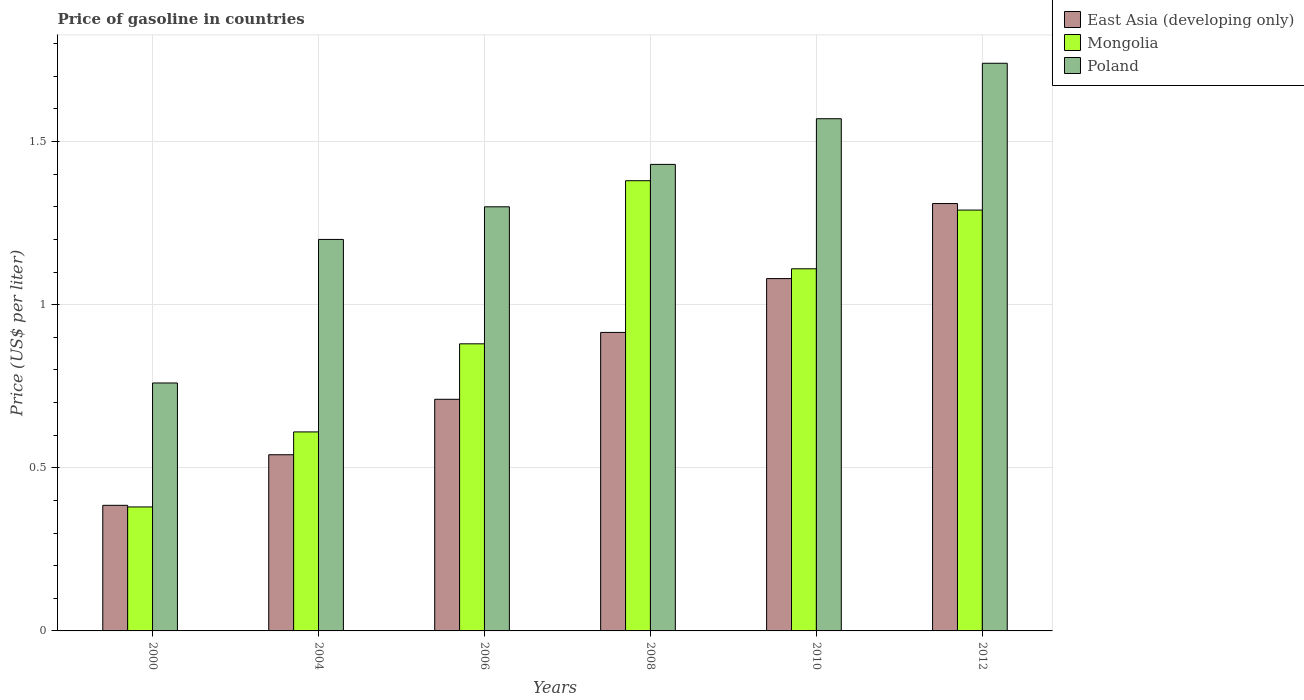How many different coloured bars are there?
Make the answer very short. 3. Are the number of bars per tick equal to the number of legend labels?
Your response must be concise. Yes. Are the number of bars on each tick of the X-axis equal?
Make the answer very short. Yes. How many bars are there on the 6th tick from the left?
Your answer should be very brief. 3. How many bars are there on the 5th tick from the right?
Ensure brevity in your answer.  3. What is the label of the 6th group of bars from the left?
Your answer should be compact. 2012. What is the price of gasoline in Poland in 2012?
Make the answer very short. 1.74. Across all years, what is the maximum price of gasoline in Mongolia?
Offer a very short reply. 1.38. Across all years, what is the minimum price of gasoline in East Asia (developing only)?
Offer a terse response. 0.39. In which year was the price of gasoline in East Asia (developing only) maximum?
Your answer should be compact. 2012. What is the total price of gasoline in East Asia (developing only) in the graph?
Your answer should be compact. 4.94. What is the difference between the price of gasoline in East Asia (developing only) in 2006 and that in 2010?
Ensure brevity in your answer.  -0.37. What is the difference between the price of gasoline in East Asia (developing only) in 2000 and the price of gasoline in Poland in 2010?
Offer a terse response. -1.19. What is the average price of gasoline in Poland per year?
Keep it short and to the point. 1.33. In the year 2012, what is the difference between the price of gasoline in Mongolia and price of gasoline in Poland?
Make the answer very short. -0.45. What is the ratio of the price of gasoline in Poland in 2006 to that in 2008?
Your answer should be compact. 0.91. What is the difference between the highest and the second highest price of gasoline in Mongolia?
Your response must be concise. 0.09. What does the 2nd bar from the left in 2000 represents?
Your response must be concise. Mongolia. Is it the case that in every year, the sum of the price of gasoline in East Asia (developing only) and price of gasoline in Mongolia is greater than the price of gasoline in Poland?
Keep it short and to the point. No. Are all the bars in the graph horizontal?
Keep it short and to the point. No. How many years are there in the graph?
Offer a very short reply. 6. What is the difference between two consecutive major ticks on the Y-axis?
Your answer should be compact. 0.5. Are the values on the major ticks of Y-axis written in scientific E-notation?
Offer a very short reply. No. Where does the legend appear in the graph?
Offer a very short reply. Top right. How are the legend labels stacked?
Ensure brevity in your answer.  Vertical. What is the title of the graph?
Ensure brevity in your answer.  Price of gasoline in countries. What is the label or title of the X-axis?
Provide a short and direct response. Years. What is the label or title of the Y-axis?
Give a very brief answer. Price (US$ per liter). What is the Price (US$ per liter) of East Asia (developing only) in 2000?
Your answer should be very brief. 0.39. What is the Price (US$ per liter) of Mongolia in 2000?
Provide a short and direct response. 0.38. What is the Price (US$ per liter) in Poland in 2000?
Provide a short and direct response. 0.76. What is the Price (US$ per liter) of East Asia (developing only) in 2004?
Make the answer very short. 0.54. What is the Price (US$ per liter) in Mongolia in 2004?
Your answer should be very brief. 0.61. What is the Price (US$ per liter) in East Asia (developing only) in 2006?
Ensure brevity in your answer.  0.71. What is the Price (US$ per liter) in Poland in 2006?
Make the answer very short. 1.3. What is the Price (US$ per liter) in East Asia (developing only) in 2008?
Offer a terse response. 0.92. What is the Price (US$ per liter) of Mongolia in 2008?
Provide a succinct answer. 1.38. What is the Price (US$ per liter) of Poland in 2008?
Your response must be concise. 1.43. What is the Price (US$ per liter) in East Asia (developing only) in 2010?
Make the answer very short. 1.08. What is the Price (US$ per liter) of Mongolia in 2010?
Give a very brief answer. 1.11. What is the Price (US$ per liter) of Poland in 2010?
Your answer should be very brief. 1.57. What is the Price (US$ per liter) in East Asia (developing only) in 2012?
Your answer should be compact. 1.31. What is the Price (US$ per liter) of Mongolia in 2012?
Offer a very short reply. 1.29. What is the Price (US$ per liter) of Poland in 2012?
Offer a very short reply. 1.74. Across all years, what is the maximum Price (US$ per liter) in East Asia (developing only)?
Make the answer very short. 1.31. Across all years, what is the maximum Price (US$ per liter) of Mongolia?
Provide a short and direct response. 1.38. Across all years, what is the maximum Price (US$ per liter) in Poland?
Give a very brief answer. 1.74. Across all years, what is the minimum Price (US$ per liter) of East Asia (developing only)?
Offer a very short reply. 0.39. Across all years, what is the minimum Price (US$ per liter) of Mongolia?
Your response must be concise. 0.38. Across all years, what is the minimum Price (US$ per liter) in Poland?
Keep it short and to the point. 0.76. What is the total Price (US$ per liter) in East Asia (developing only) in the graph?
Provide a succinct answer. 4.94. What is the total Price (US$ per liter) in Mongolia in the graph?
Offer a terse response. 5.65. What is the difference between the Price (US$ per liter) of East Asia (developing only) in 2000 and that in 2004?
Keep it short and to the point. -0.15. What is the difference between the Price (US$ per liter) in Mongolia in 2000 and that in 2004?
Provide a short and direct response. -0.23. What is the difference between the Price (US$ per liter) of Poland in 2000 and that in 2004?
Offer a terse response. -0.44. What is the difference between the Price (US$ per liter) of East Asia (developing only) in 2000 and that in 2006?
Provide a succinct answer. -0.33. What is the difference between the Price (US$ per liter) of Poland in 2000 and that in 2006?
Provide a short and direct response. -0.54. What is the difference between the Price (US$ per liter) of East Asia (developing only) in 2000 and that in 2008?
Make the answer very short. -0.53. What is the difference between the Price (US$ per liter) in Mongolia in 2000 and that in 2008?
Keep it short and to the point. -1. What is the difference between the Price (US$ per liter) in Poland in 2000 and that in 2008?
Keep it short and to the point. -0.67. What is the difference between the Price (US$ per liter) in East Asia (developing only) in 2000 and that in 2010?
Ensure brevity in your answer.  -0.69. What is the difference between the Price (US$ per liter) in Mongolia in 2000 and that in 2010?
Your answer should be very brief. -0.73. What is the difference between the Price (US$ per liter) of Poland in 2000 and that in 2010?
Offer a terse response. -0.81. What is the difference between the Price (US$ per liter) in East Asia (developing only) in 2000 and that in 2012?
Your answer should be very brief. -0.93. What is the difference between the Price (US$ per liter) of Mongolia in 2000 and that in 2012?
Offer a terse response. -0.91. What is the difference between the Price (US$ per liter) of Poland in 2000 and that in 2012?
Your answer should be very brief. -0.98. What is the difference between the Price (US$ per liter) of East Asia (developing only) in 2004 and that in 2006?
Your answer should be compact. -0.17. What is the difference between the Price (US$ per liter) in Mongolia in 2004 and that in 2006?
Your answer should be very brief. -0.27. What is the difference between the Price (US$ per liter) of East Asia (developing only) in 2004 and that in 2008?
Provide a short and direct response. -0.38. What is the difference between the Price (US$ per liter) in Mongolia in 2004 and that in 2008?
Offer a terse response. -0.77. What is the difference between the Price (US$ per liter) of Poland in 2004 and that in 2008?
Keep it short and to the point. -0.23. What is the difference between the Price (US$ per liter) of East Asia (developing only) in 2004 and that in 2010?
Keep it short and to the point. -0.54. What is the difference between the Price (US$ per liter) in Mongolia in 2004 and that in 2010?
Keep it short and to the point. -0.5. What is the difference between the Price (US$ per liter) in Poland in 2004 and that in 2010?
Offer a very short reply. -0.37. What is the difference between the Price (US$ per liter) of East Asia (developing only) in 2004 and that in 2012?
Provide a succinct answer. -0.77. What is the difference between the Price (US$ per liter) of Mongolia in 2004 and that in 2012?
Ensure brevity in your answer.  -0.68. What is the difference between the Price (US$ per liter) in Poland in 2004 and that in 2012?
Your response must be concise. -0.54. What is the difference between the Price (US$ per liter) of East Asia (developing only) in 2006 and that in 2008?
Offer a very short reply. -0.2. What is the difference between the Price (US$ per liter) in Mongolia in 2006 and that in 2008?
Ensure brevity in your answer.  -0.5. What is the difference between the Price (US$ per liter) of Poland in 2006 and that in 2008?
Keep it short and to the point. -0.13. What is the difference between the Price (US$ per liter) of East Asia (developing only) in 2006 and that in 2010?
Offer a terse response. -0.37. What is the difference between the Price (US$ per liter) of Mongolia in 2006 and that in 2010?
Offer a very short reply. -0.23. What is the difference between the Price (US$ per liter) of Poland in 2006 and that in 2010?
Ensure brevity in your answer.  -0.27. What is the difference between the Price (US$ per liter) of East Asia (developing only) in 2006 and that in 2012?
Offer a very short reply. -0.6. What is the difference between the Price (US$ per liter) in Mongolia in 2006 and that in 2012?
Your answer should be compact. -0.41. What is the difference between the Price (US$ per liter) in Poland in 2006 and that in 2012?
Provide a succinct answer. -0.44. What is the difference between the Price (US$ per liter) of East Asia (developing only) in 2008 and that in 2010?
Your response must be concise. -0.17. What is the difference between the Price (US$ per liter) in Mongolia in 2008 and that in 2010?
Keep it short and to the point. 0.27. What is the difference between the Price (US$ per liter) of Poland in 2008 and that in 2010?
Give a very brief answer. -0.14. What is the difference between the Price (US$ per liter) in East Asia (developing only) in 2008 and that in 2012?
Make the answer very short. -0.4. What is the difference between the Price (US$ per liter) in Mongolia in 2008 and that in 2012?
Offer a very short reply. 0.09. What is the difference between the Price (US$ per liter) in Poland in 2008 and that in 2012?
Provide a short and direct response. -0.31. What is the difference between the Price (US$ per liter) of East Asia (developing only) in 2010 and that in 2012?
Offer a very short reply. -0.23. What is the difference between the Price (US$ per liter) of Mongolia in 2010 and that in 2012?
Ensure brevity in your answer.  -0.18. What is the difference between the Price (US$ per liter) in Poland in 2010 and that in 2012?
Provide a succinct answer. -0.17. What is the difference between the Price (US$ per liter) of East Asia (developing only) in 2000 and the Price (US$ per liter) of Mongolia in 2004?
Your answer should be very brief. -0.23. What is the difference between the Price (US$ per liter) of East Asia (developing only) in 2000 and the Price (US$ per liter) of Poland in 2004?
Ensure brevity in your answer.  -0.81. What is the difference between the Price (US$ per liter) of Mongolia in 2000 and the Price (US$ per liter) of Poland in 2004?
Your answer should be very brief. -0.82. What is the difference between the Price (US$ per liter) in East Asia (developing only) in 2000 and the Price (US$ per liter) in Mongolia in 2006?
Offer a very short reply. -0.49. What is the difference between the Price (US$ per liter) in East Asia (developing only) in 2000 and the Price (US$ per liter) in Poland in 2006?
Offer a very short reply. -0.92. What is the difference between the Price (US$ per liter) in Mongolia in 2000 and the Price (US$ per liter) in Poland in 2006?
Make the answer very short. -0.92. What is the difference between the Price (US$ per liter) of East Asia (developing only) in 2000 and the Price (US$ per liter) of Mongolia in 2008?
Your answer should be very brief. -0.99. What is the difference between the Price (US$ per liter) of East Asia (developing only) in 2000 and the Price (US$ per liter) of Poland in 2008?
Your answer should be compact. -1.04. What is the difference between the Price (US$ per liter) in Mongolia in 2000 and the Price (US$ per liter) in Poland in 2008?
Keep it short and to the point. -1.05. What is the difference between the Price (US$ per liter) in East Asia (developing only) in 2000 and the Price (US$ per liter) in Mongolia in 2010?
Ensure brevity in your answer.  -0.72. What is the difference between the Price (US$ per liter) in East Asia (developing only) in 2000 and the Price (US$ per liter) in Poland in 2010?
Your answer should be very brief. -1.19. What is the difference between the Price (US$ per liter) in Mongolia in 2000 and the Price (US$ per liter) in Poland in 2010?
Provide a succinct answer. -1.19. What is the difference between the Price (US$ per liter) in East Asia (developing only) in 2000 and the Price (US$ per liter) in Mongolia in 2012?
Make the answer very short. -0.91. What is the difference between the Price (US$ per liter) in East Asia (developing only) in 2000 and the Price (US$ per liter) in Poland in 2012?
Give a very brief answer. -1.35. What is the difference between the Price (US$ per liter) of Mongolia in 2000 and the Price (US$ per liter) of Poland in 2012?
Offer a terse response. -1.36. What is the difference between the Price (US$ per liter) in East Asia (developing only) in 2004 and the Price (US$ per liter) in Mongolia in 2006?
Your answer should be very brief. -0.34. What is the difference between the Price (US$ per liter) in East Asia (developing only) in 2004 and the Price (US$ per liter) in Poland in 2006?
Your response must be concise. -0.76. What is the difference between the Price (US$ per liter) in Mongolia in 2004 and the Price (US$ per liter) in Poland in 2006?
Provide a succinct answer. -0.69. What is the difference between the Price (US$ per liter) in East Asia (developing only) in 2004 and the Price (US$ per liter) in Mongolia in 2008?
Your response must be concise. -0.84. What is the difference between the Price (US$ per liter) of East Asia (developing only) in 2004 and the Price (US$ per liter) of Poland in 2008?
Keep it short and to the point. -0.89. What is the difference between the Price (US$ per liter) in Mongolia in 2004 and the Price (US$ per liter) in Poland in 2008?
Offer a very short reply. -0.82. What is the difference between the Price (US$ per liter) of East Asia (developing only) in 2004 and the Price (US$ per liter) of Mongolia in 2010?
Make the answer very short. -0.57. What is the difference between the Price (US$ per liter) of East Asia (developing only) in 2004 and the Price (US$ per liter) of Poland in 2010?
Offer a very short reply. -1.03. What is the difference between the Price (US$ per liter) in Mongolia in 2004 and the Price (US$ per liter) in Poland in 2010?
Your response must be concise. -0.96. What is the difference between the Price (US$ per liter) of East Asia (developing only) in 2004 and the Price (US$ per liter) of Mongolia in 2012?
Give a very brief answer. -0.75. What is the difference between the Price (US$ per liter) of East Asia (developing only) in 2004 and the Price (US$ per liter) of Poland in 2012?
Offer a very short reply. -1.2. What is the difference between the Price (US$ per liter) of Mongolia in 2004 and the Price (US$ per liter) of Poland in 2012?
Your answer should be compact. -1.13. What is the difference between the Price (US$ per liter) of East Asia (developing only) in 2006 and the Price (US$ per liter) of Mongolia in 2008?
Provide a short and direct response. -0.67. What is the difference between the Price (US$ per liter) of East Asia (developing only) in 2006 and the Price (US$ per liter) of Poland in 2008?
Your answer should be compact. -0.72. What is the difference between the Price (US$ per liter) of Mongolia in 2006 and the Price (US$ per liter) of Poland in 2008?
Offer a very short reply. -0.55. What is the difference between the Price (US$ per liter) in East Asia (developing only) in 2006 and the Price (US$ per liter) in Poland in 2010?
Keep it short and to the point. -0.86. What is the difference between the Price (US$ per liter) in Mongolia in 2006 and the Price (US$ per liter) in Poland in 2010?
Your answer should be very brief. -0.69. What is the difference between the Price (US$ per liter) of East Asia (developing only) in 2006 and the Price (US$ per liter) of Mongolia in 2012?
Offer a very short reply. -0.58. What is the difference between the Price (US$ per liter) in East Asia (developing only) in 2006 and the Price (US$ per liter) in Poland in 2012?
Offer a terse response. -1.03. What is the difference between the Price (US$ per liter) of Mongolia in 2006 and the Price (US$ per liter) of Poland in 2012?
Give a very brief answer. -0.86. What is the difference between the Price (US$ per liter) of East Asia (developing only) in 2008 and the Price (US$ per liter) of Mongolia in 2010?
Keep it short and to the point. -0.2. What is the difference between the Price (US$ per liter) of East Asia (developing only) in 2008 and the Price (US$ per liter) of Poland in 2010?
Give a very brief answer. -0.66. What is the difference between the Price (US$ per liter) in Mongolia in 2008 and the Price (US$ per liter) in Poland in 2010?
Provide a short and direct response. -0.19. What is the difference between the Price (US$ per liter) in East Asia (developing only) in 2008 and the Price (US$ per liter) in Mongolia in 2012?
Offer a very short reply. -0.38. What is the difference between the Price (US$ per liter) in East Asia (developing only) in 2008 and the Price (US$ per liter) in Poland in 2012?
Ensure brevity in your answer.  -0.82. What is the difference between the Price (US$ per liter) of Mongolia in 2008 and the Price (US$ per liter) of Poland in 2012?
Give a very brief answer. -0.36. What is the difference between the Price (US$ per liter) of East Asia (developing only) in 2010 and the Price (US$ per liter) of Mongolia in 2012?
Your response must be concise. -0.21. What is the difference between the Price (US$ per liter) in East Asia (developing only) in 2010 and the Price (US$ per liter) in Poland in 2012?
Your answer should be compact. -0.66. What is the difference between the Price (US$ per liter) in Mongolia in 2010 and the Price (US$ per liter) in Poland in 2012?
Provide a short and direct response. -0.63. What is the average Price (US$ per liter) in East Asia (developing only) per year?
Provide a short and direct response. 0.82. What is the average Price (US$ per liter) in Mongolia per year?
Your answer should be compact. 0.94. What is the average Price (US$ per liter) in Poland per year?
Keep it short and to the point. 1.33. In the year 2000, what is the difference between the Price (US$ per liter) of East Asia (developing only) and Price (US$ per liter) of Mongolia?
Make the answer very short. 0.01. In the year 2000, what is the difference between the Price (US$ per liter) in East Asia (developing only) and Price (US$ per liter) in Poland?
Offer a very short reply. -0.38. In the year 2000, what is the difference between the Price (US$ per liter) in Mongolia and Price (US$ per liter) in Poland?
Your response must be concise. -0.38. In the year 2004, what is the difference between the Price (US$ per liter) in East Asia (developing only) and Price (US$ per liter) in Mongolia?
Ensure brevity in your answer.  -0.07. In the year 2004, what is the difference between the Price (US$ per liter) in East Asia (developing only) and Price (US$ per liter) in Poland?
Provide a succinct answer. -0.66. In the year 2004, what is the difference between the Price (US$ per liter) in Mongolia and Price (US$ per liter) in Poland?
Offer a very short reply. -0.59. In the year 2006, what is the difference between the Price (US$ per liter) of East Asia (developing only) and Price (US$ per liter) of Mongolia?
Provide a short and direct response. -0.17. In the year 2006, what is the difference between the Price (US$ per liter) of East Asia (developing only) and Price (US$ per liter) of Poland?
Give a very brief answer. -0.59. In the year 2006, what is the difference between the Price (US$ per liter) in Mongolia and Price (US$ per liter) in Poland?
Offer a terse response. -0.42. In the year 2008, what is the difference between the Price (US$ per liter) of East Asia (developing only) and Price (US$ per liter) of Mongolia?
Your answer should be compact. -0.47. In the year 2008, what is the difference between the Price (US$ per liter) of East Asia (developing only) and Price (US$ per liter) of Poland?
Your answer should be very brief. -0.52. In the year 2008, what is the difference between the Price (US$ per liter) of Mongolia and Price (US$ per liter) of Poland?
Your response must be concise. -0.05. In the year 2010, what is the difference between the Price (US$ per liter) of East Asia (developing only) and Price (US$ per liter) of Mongolia?
Your response must be concise. -0.03. In the year 2010, what is the difference between the Price (US$ per liter) of East Asia (developing only) and Price (US$ per liter) of Poland?
Keep it short and to the point. -0.49. In the year 2010, what is the difference between the Price (US$ per liter) in Mongolia and Price (US$ per liter) in Poland?
Provide a short and direct response. -0.46. In the year 2012, what is the difference between the Price (US$ per liter) in East Asia (developing only) and Price (US$ per liter) in Mongolia?
Ensure brevity in your answer.  0.02. In the year 2012, what is the difference between the Price (US$ per liter) in East Asia (developing only) and Price (US$ per liter) in Poland?
Your answer should be compact. -0.43. In the year 2012, what is the difference between the Price (US$ per liter) of Mongolia and Price (US$ per liter) of Poland?
Provide a succinct answer. -0.45. What is the ratio of the Price (US$ per liter) in East Asia (developing only) in 2000 to that in 2004?
Give a very brief answer. 0.71. What is the ratio of the Price (US$ per liter) of Mongolia in 2000 to that in 2004?
Provide a short and direct response. 0.62. What is the ratio of the Price (US$ per liter) of Poland in 2000 to that in 2004?
Provide a short and direct response. 0.63. What is the ratio of the Price (US$ per liter) of East Asia (developing only) in 2000 to that in 2006?
Your answer should be very brief. 0.54. What is the ratio of the Price (US$ per liter) of Mongolia in 2000 to that in 2006?
Offer a terse response. 0.43. What is the ratio of the Price (US$ per liter) in Poland in 2000 to that in 2006?
Give a very brief answer. 0.58. What is the ratio of the Price (US$ per liter) in East Asia (developing only) in 2000 to that in 2008?
Your response must be concise. 0.42. What is the ratio of the Price (US$ per liter) of Mongolia in 2000 to that in 2008?
Provide a succinct answer. 0.28. What is the ratio of the Price (US$ per liter) of Poland in 2000 to that in 2008?
Keep it short and to the point. 0.53. What is the ratio of the Price (US$ per liter) in East Asia (developing only) in 2000 to that in 2010?
Provide a short and direct response. 0.36. What is the ratio of the Price (US$ per liter) in Mongolia in 2000 to that in 2010?
Your answer should be very brief. 0.34. What is the ratio of the Price (US$ per liter) in Poland in 2000 to that in 2010?
Your answer should be compact. 0.48. What is the ratio of the Price (US$ per liter) in East Asia (developing only) in 2000 to that in 2012?
Your answer should be very brief. 0.29. What is the ratio of the Price (US$ per liter) in Mongolia in 2000 to that in 2012?
Give a very brief answer. 0.29. What is the ratio of the Price (US$ per liter) of Poland in 2000 to that in 2012?
Your response must be concise. 0.44. What is the ratio of the Price (US$ per liter) of East Asia (developing only) in 2004 to that in 2006?
Make the answer very short. 0.76. What is the ratio of the Price (US$ per liter) in Mongolia in 2004 to that in 2006?
Offer a very short reply. 0.69. What is the ratio of the Price (US$ per liter) in East Asia (developing only) in 2004 to that in 2008?
Offer a terse response. 0.59. What is the ratio of the Price (US$ per liter) of Mongolia in 2004 to that in 2008?
Make the answer very short. 0.44. What is the ratio of the Price (US$ per liter) in Poland in 2004 to that in 2008?
Give a very brief answer. 0.84. What is the ratio of the Price (US$ per liter) in East Asia (developing only) in 2004 to that in 2010?
Give a very brief answer. 0.5. What is the ratio of the Price (US$ per liter) of Mongolia in 2004 to that in 2010?
Offer a very short reply. 0.55. What is the ratio of the Price (US$ per liter) in Poland in 2004 to that in 2010?
Your answer should be compact. 0.76. What is the ratio of the Price (US$ per liter) of East Asia (developing only) in 2004 to that in 2012?
Ensure brevity in your answer.  0.41. What is the ratio of the Price (US$ per liter) of Mongolia in 2004 to that in 2012?
Make the answer very short. 0.47. What is the ratio of the Price (US$ per liter) of Poland in 2004 to that in 2012?
Your answer should be very brief. 0.69. What is the ratio of the Price (US$ per liter) of East Asia (developing only) in 2006 to that in 2008?
Offer a terse response. 0.78. What is the ratio of the Price (US$ per liter) of Mongolia in 2006 to that in 2008?
Your answer should be compact. 0.64. What is the ratio of the Price (US$ per liter) in Poland in 2006 to that in 2008?
Provide a short and direct response. 0.91. What is the ratio of the Price (US$ per liter) of East Asia (developing only) in 2006 to that in 2010?
Provide a short and direct response. 0.66. What is the ratio of the Price (US$ per liter) in Mongolia in 2006 to that in 2010?
Provide a succinct answer. 0.79. What is the ratio of the Price (US$ per liter) in Poland in 2006 to that in 2010?
Ensure brevity in your answer.  0.83. What is the ratio of the Price (US$ per liter) in East Asia (developing only) in 2006 to that in 2012?
Provide a short and direct response. 0.54. What is the ratio of the Price (US$ per liter) of Mongolia in 2006 to that in 2012?
Provide a short and direct response. 0.68. What is the ratio of the Price (US$ per liter) in Poland in 2006 to that in 2012?
Provide a short and direct response. 0.75. What is the ratio of the Price (US$ per liter) in East Asia (developing only) in 2008 to that in 2010?
Ensure brevity in your answer.  0.85. What is the ratio of the Price (US$ per liter) in Mongolia in 2008 to that in 2010?
Give a very brief answer. 1.24. What is the ratio of the Price (US$ per liter) in Poland in 2008 to that in 2010?
Ensure brevity in your answer.  0.91. What is the ratio of the Price (US$ per liter) of East Asia (developing only) in 2008 to that in 2012?
Provide a short and direct response. 0.7. What is the ratio of the Price (US$ per liter) in Mongolia in 2008 to that in 2012?
Your answer should be compact. 1.07. What is the ratio of the Price (US$ per liter) in Poland in 2008 to that in 2012?
Provide a succinct answer. 0.82. What is the ratio of the Price (US$ per liter) of East Asia (developing only) in 2010 to that in 2012?
Make the answer very short. 0.82. What is the ratio of the Price (US$ per liter) of Mongolia in 2010 to that in 2012?
Provide a succinct answer. 0.86. What is the ratio of the Price (US$ per liter) in Poland in 2010 to that in 2012?
Your answer should be very brief. 0.9. What is the difference between the highest and the second highest Price (US$ per liter) in East Asia (developing only)?
Provide a succinct answer. 0.23. What is the difference between the highest and the second highest Price (US$ per liter) of Mongolia?
Offer a terse response. 0.09. What is the difference between the highest and the second highest Price (US$ per liter) of Poland?
Keep it short and to the point. 0.17. What is the difference between the highest and the lowest Price (US$ per liter) in East Asia (developing only)?
Keep it short and to the point. 0.93. 